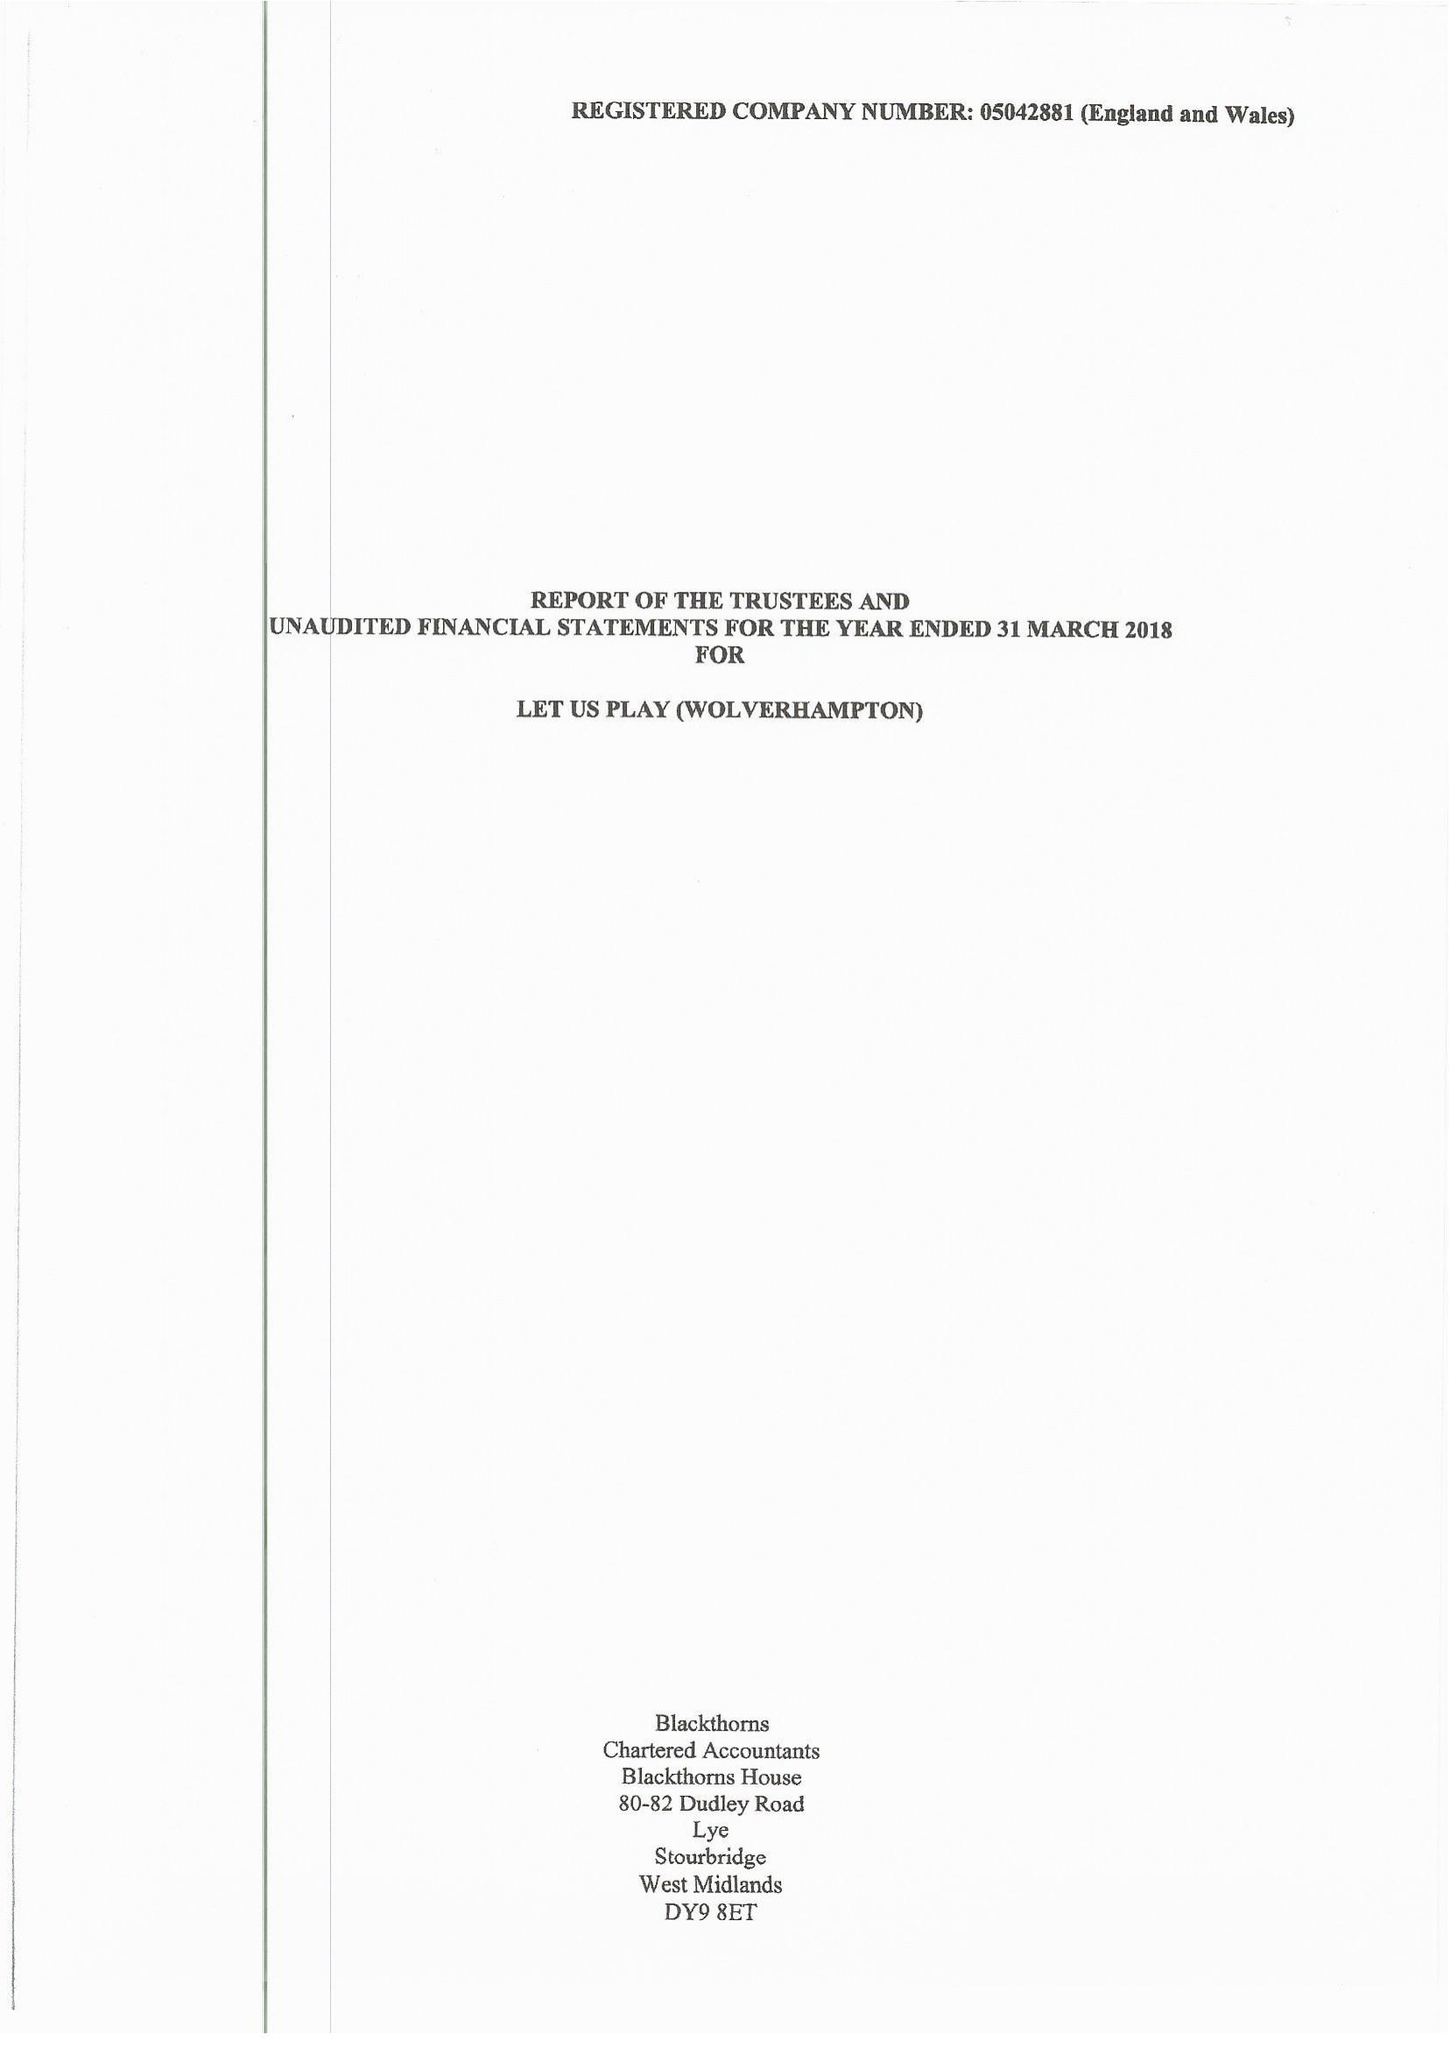What is the value for the address__street_line?
Answer the question using a single word or phrase. SHAW ROAD 